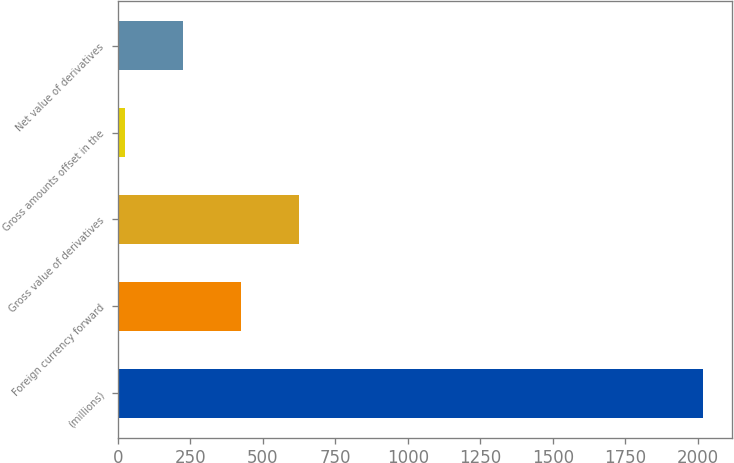Convert chart. <chart><loc_0><loc_0><loc_500><loc_500><bar_chart><fcel>(millions)<fcel>Foreign currency forward<fcel>Gross value of derivatives<fcel>Gross amounts offset in the<fcel>Net value of derivatives<nl><fcel>2016<fcel>423.76<fcel>622.79<fcel>25.7<fcel>224.73<nl></chart> 